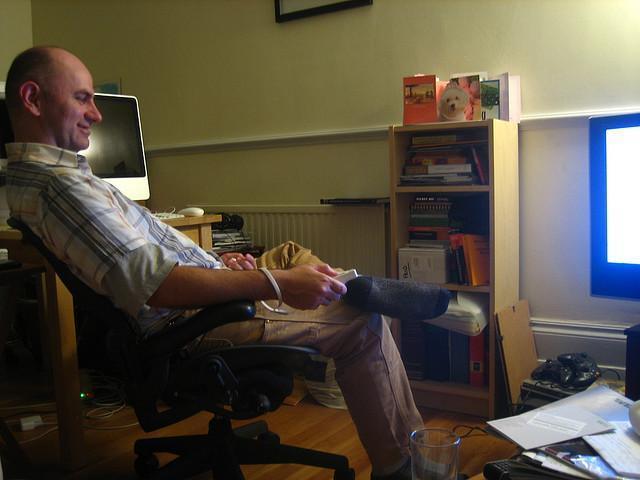How many books can you see?
Give a very brief answer. 2. How many tvs are there?
Give a very brief answer. 2. 